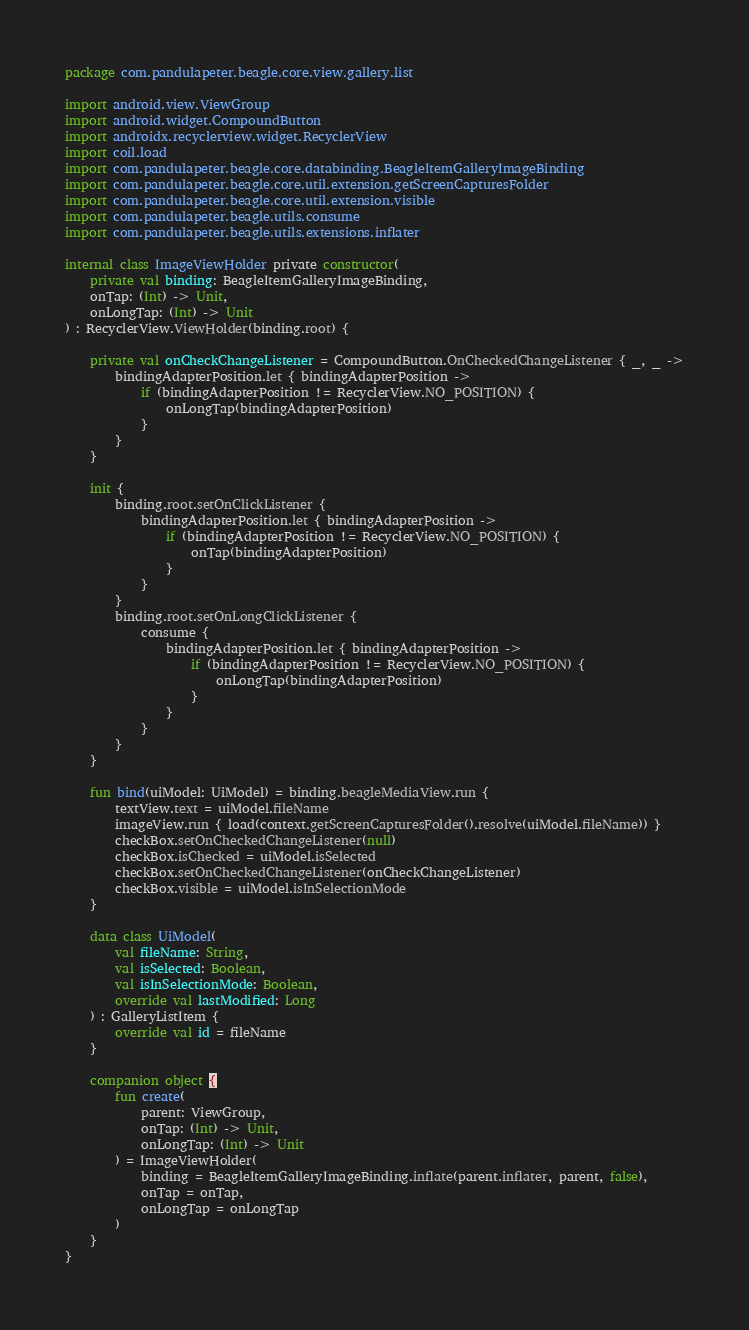<code> <loc_0><loc_0><loc_500><loc_500><_Kotlin_>package com.pandulapeter.beagle.core.view.gallery.list

import android.view.ViewGroup
import android.widget.CompoundButton
import androidx.recyclerview.widget.RecyclerView
import coil.load
import com.pandulapeter.beagle.core.databinding.BeagleItemGalleryImageBinding
import com.pandulapeter.beagle.core.util.extension.getScreenCapturesFolder
import com.pandulapeter.beagle.core.util.extension.visible
import com.pandulapeter.beagle.utils.consume
import com.pandulapeter.beagle.utils.extensions.inflater

internal class ImageViewHolder private constructor(
    private val binding: BeagleItemGalleryImageBinding,
    onTap: (Int) -> Unit,
    onLongTap: (Int) -> Unit
) : RecyclerView.ViewHolder(binding.root) {

    private val onCheckChangeListener = CompoundButton.OnCheckedChangeListener { _, _ ->
        bindingAdapterPosition.let { bindingAdapterPosition ->
            if (bindingAdapterPosition != RecyclerView.NO_POSITION) {
                onLongTap(bindingAdapterPosition)
            }
        }
    }

    init {
        binding.root.setOnClickListener {
            bindingAdapterPosition.let { bindingAdapterPosition ->
                if (bindingAdapterPosition != RecyclerView.NO_POSITION) {
                    onTap(bindingAdapterPosition)
                }
            }
        }
        binding.root.setOnLongClickListener {
            consume {
                bindingAdapterPosition.let { bindingAdapterPosition ->
                    if (bindingAdapterPosition != RecyclerView.NO_POSITION) {
                        onLongTap(bindingAdapterPosition)
                    }
                }
            }
        }
    }

    fun bind(uiModel: UiModel) = binding.beagleMediaView.run {
        textView.text = uiModel.fileName
        imageView.run { load(context.getScreenCapturesFolder().resolve(uiModel.fileName)) }
        checkBox.setOnCheckedChangeListener(null)
        checkBox.isChecked = uiModel.isSelected
        checkBox.setOnCheckedChangeListener(onCheckChangeListener)
        checkBox.visible = uiModel.isInSelectionMode
    }

    data class UiModel(
        val fileName: String,
        val isSelected: Boolean,
        val isInSelectionMode: Boolean,
        override val lastModified: Long
    ) : GalleryListItem {
        override val id = fileName
    }

    companion object {
        fun create(
            parent: ViewGroup,
            onTap: (Int) -> Unit,
            onLongTap: (Int) -> Unit
        ) = ImageViewHolder(
            binding = BeagleItemGalleryImageBinding.inflate(parent.inflater, parent, false),
            onTap = onTap,
            onLongTap = onLongTap
        )
    }
}</code> 